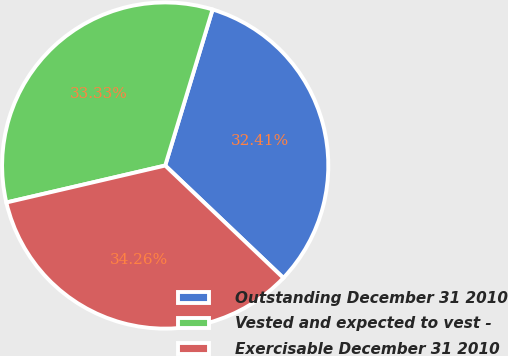Convert chart to OTSL. <chart><loc_0><loc_0><loc_500><loc_500><pie_chart><fcel>Outstanding December 31 2010<fcel>Vested and expected to vest -<fcel>Exercisable December 31 2010<nl><fcel>32.41%<fcel>33.33%<fcel>34.26%<nl></chart> 